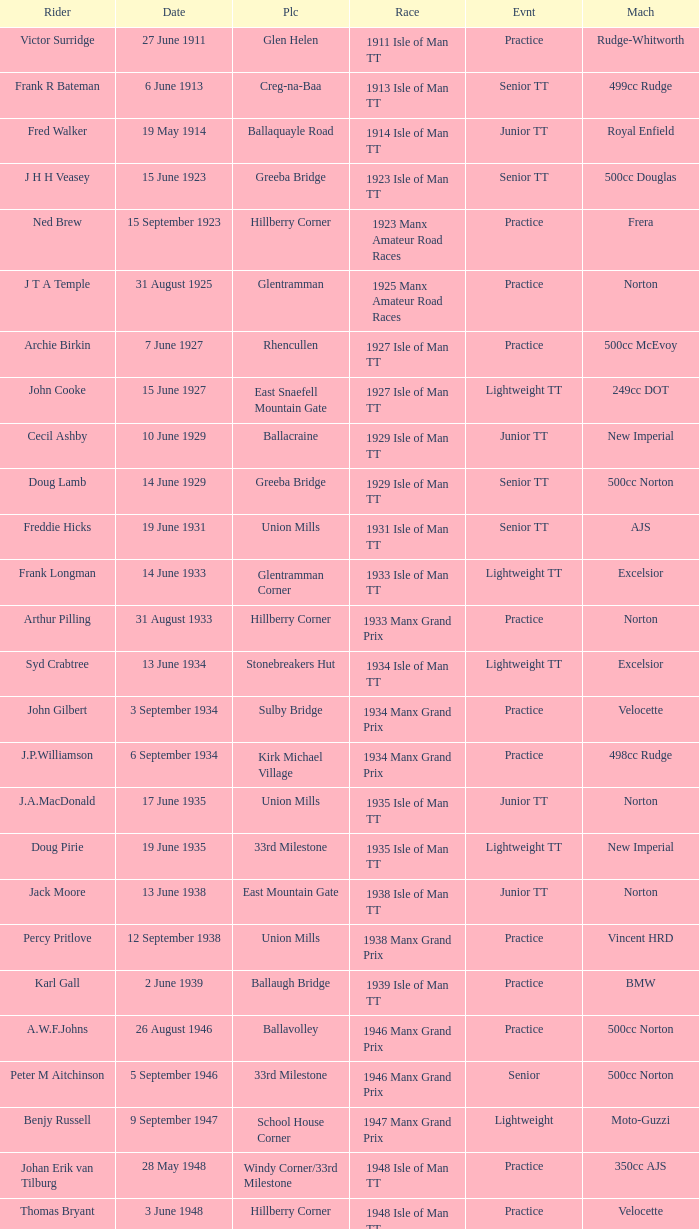What machine did Keith T. Gawler ride? 499cc Norton. 